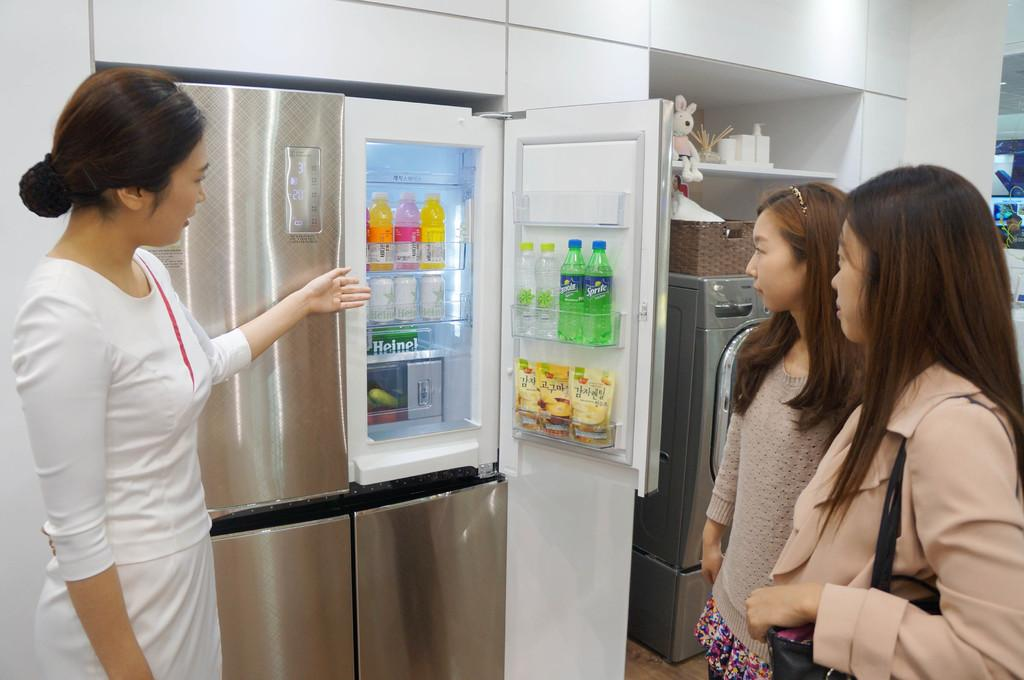<image>
Write a terse but informative summary of the picture. a lady opens a fridge with a Sprite inside the door 